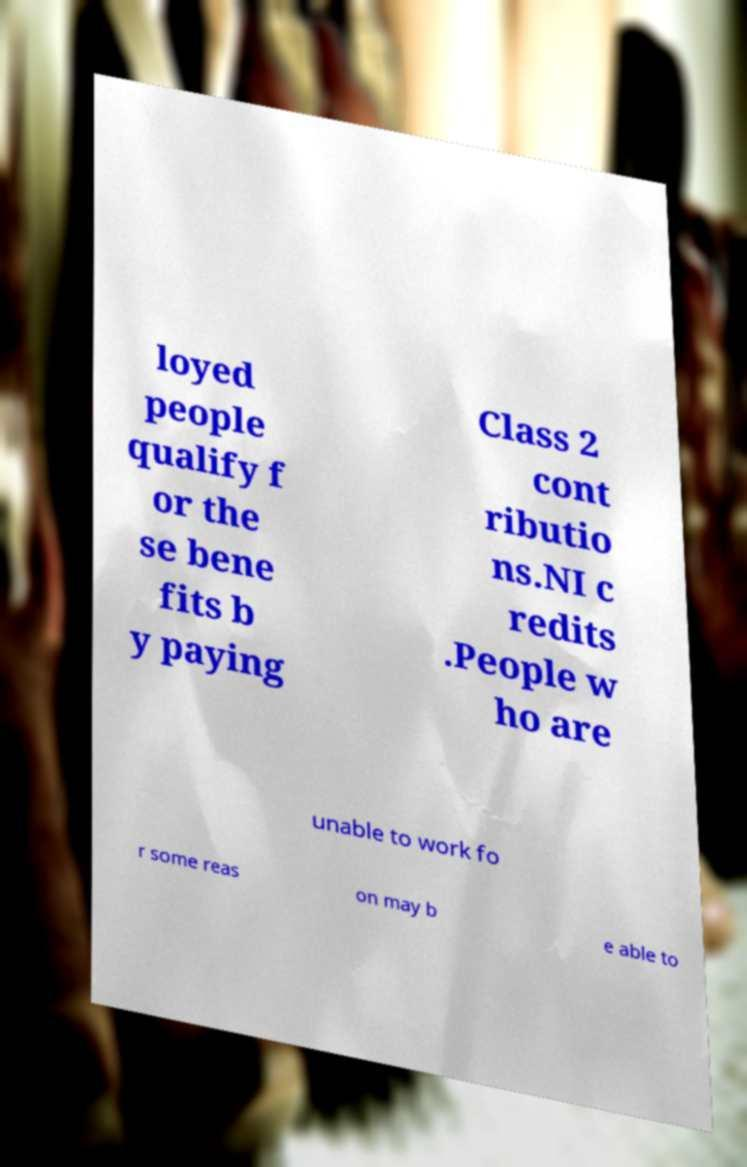Please read and relay the text visible in this image. What does it say? loyed people qualify f or the se bene fits b y paying Class 2 cont ributio ns.NI c redits .People w ho are unable to work fo r some reas on may b e able to 